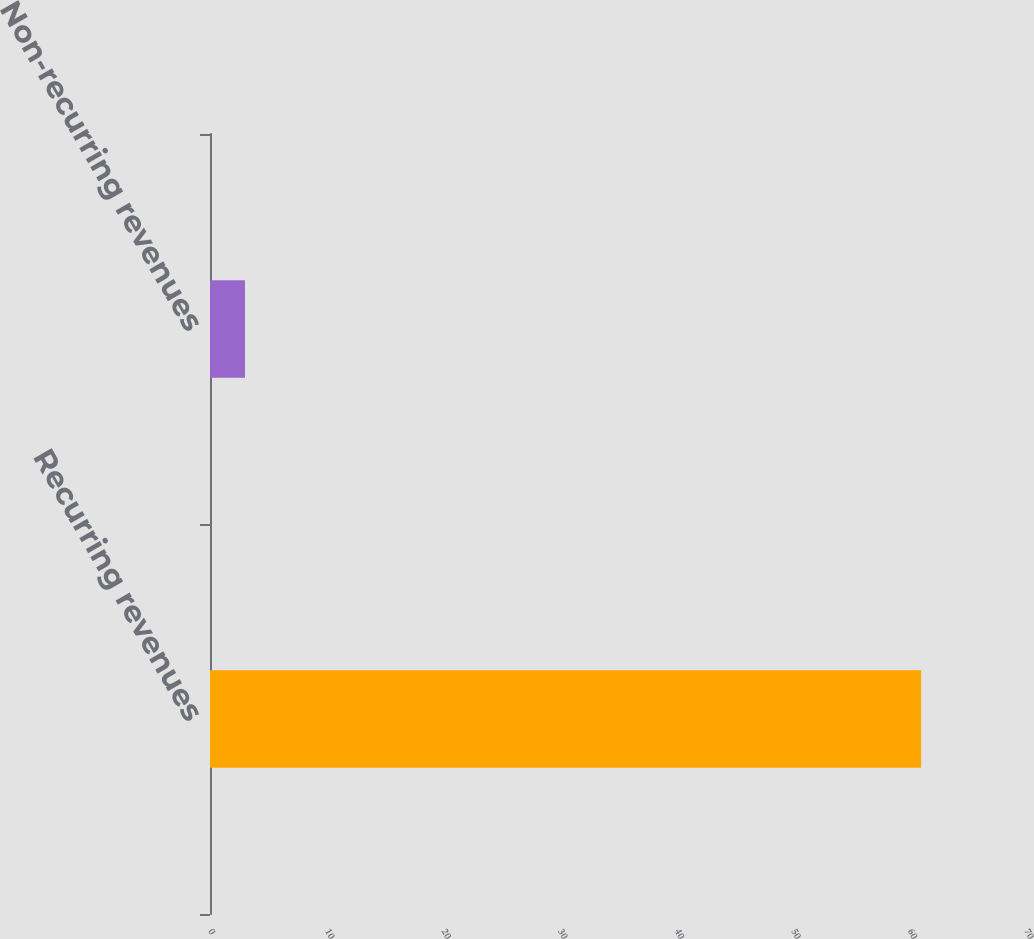Convert chart to OTSL. <chart><loc_0><loc_0><loc_500><loc_500><bar_chart><fcel>Recurring revenues<fcel>Non-recurring revenues<nl><fcel>61<fcel>3<nl></chart> 